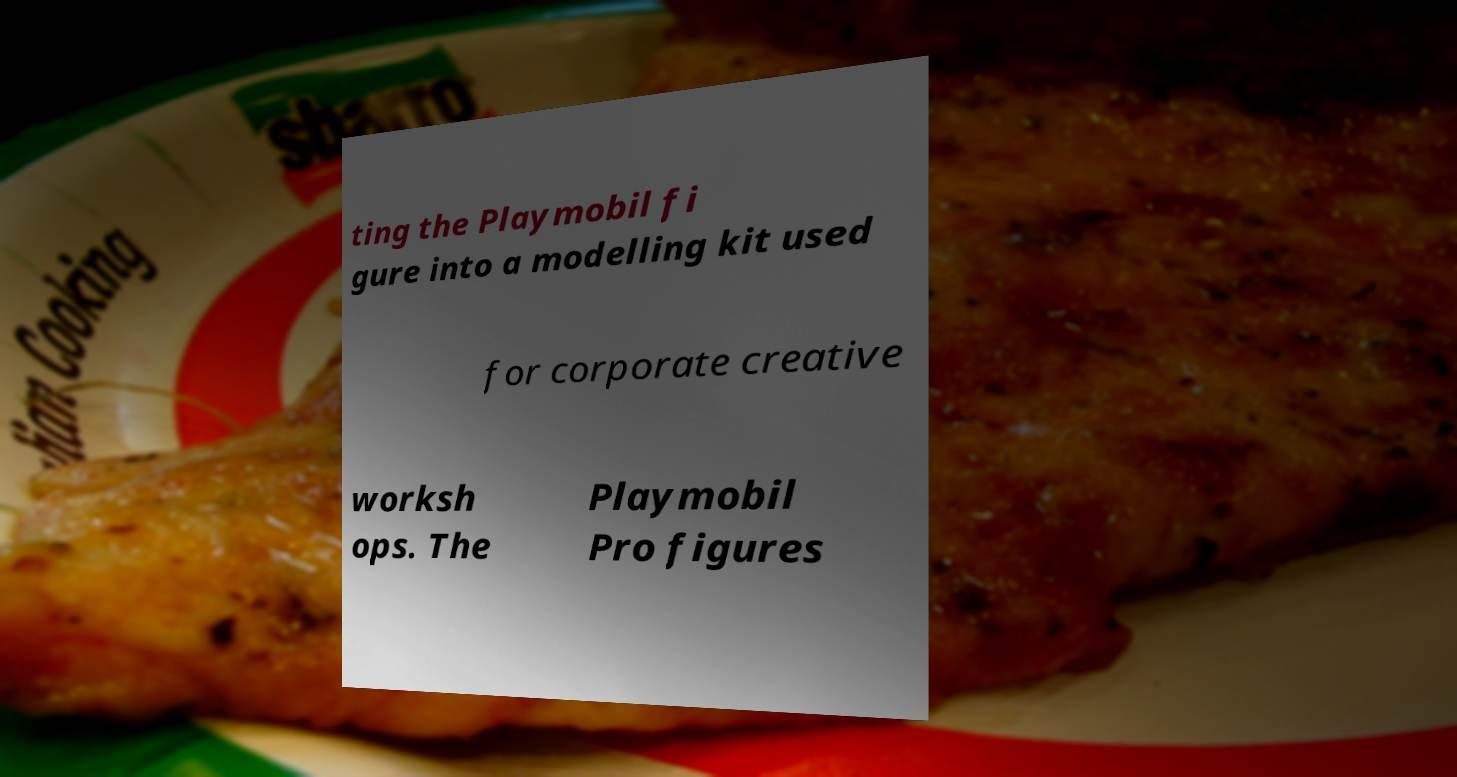Please read and relay the text visible in this image. What does it say? ting the Playmobil fi gure into a modelling kit used for corporate creative worksh ops. The Playmobil Pro figures 